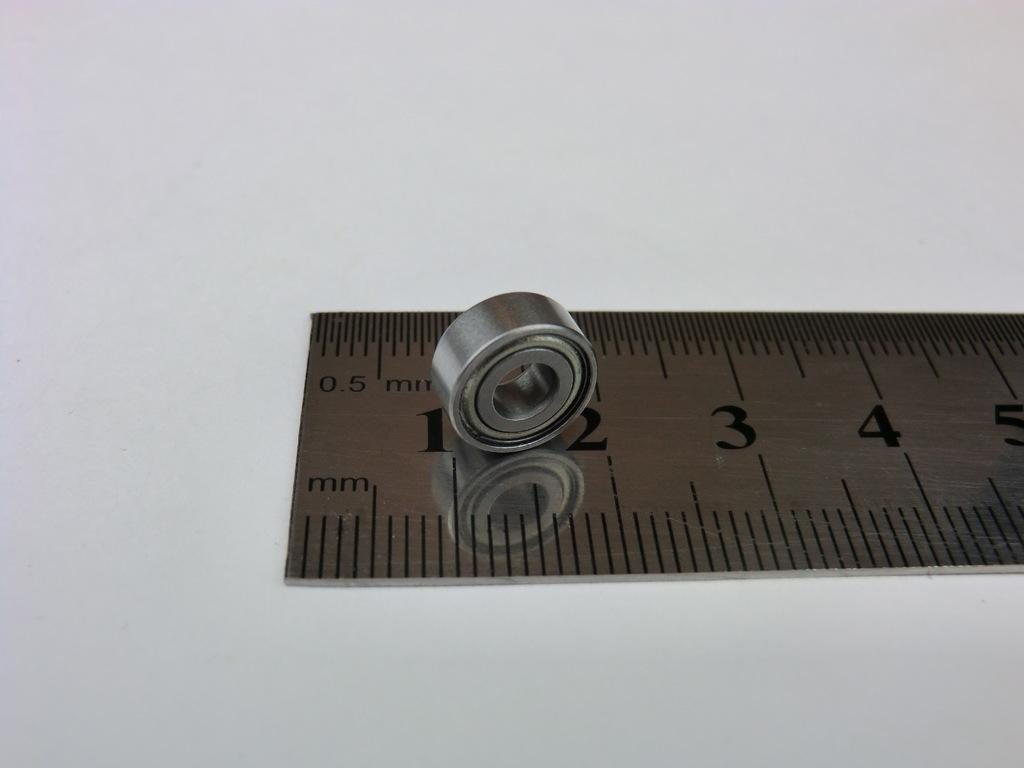<image>
Summarize the visual content of the image. A metal ruler has 0.5 mm on the upper left corner. 